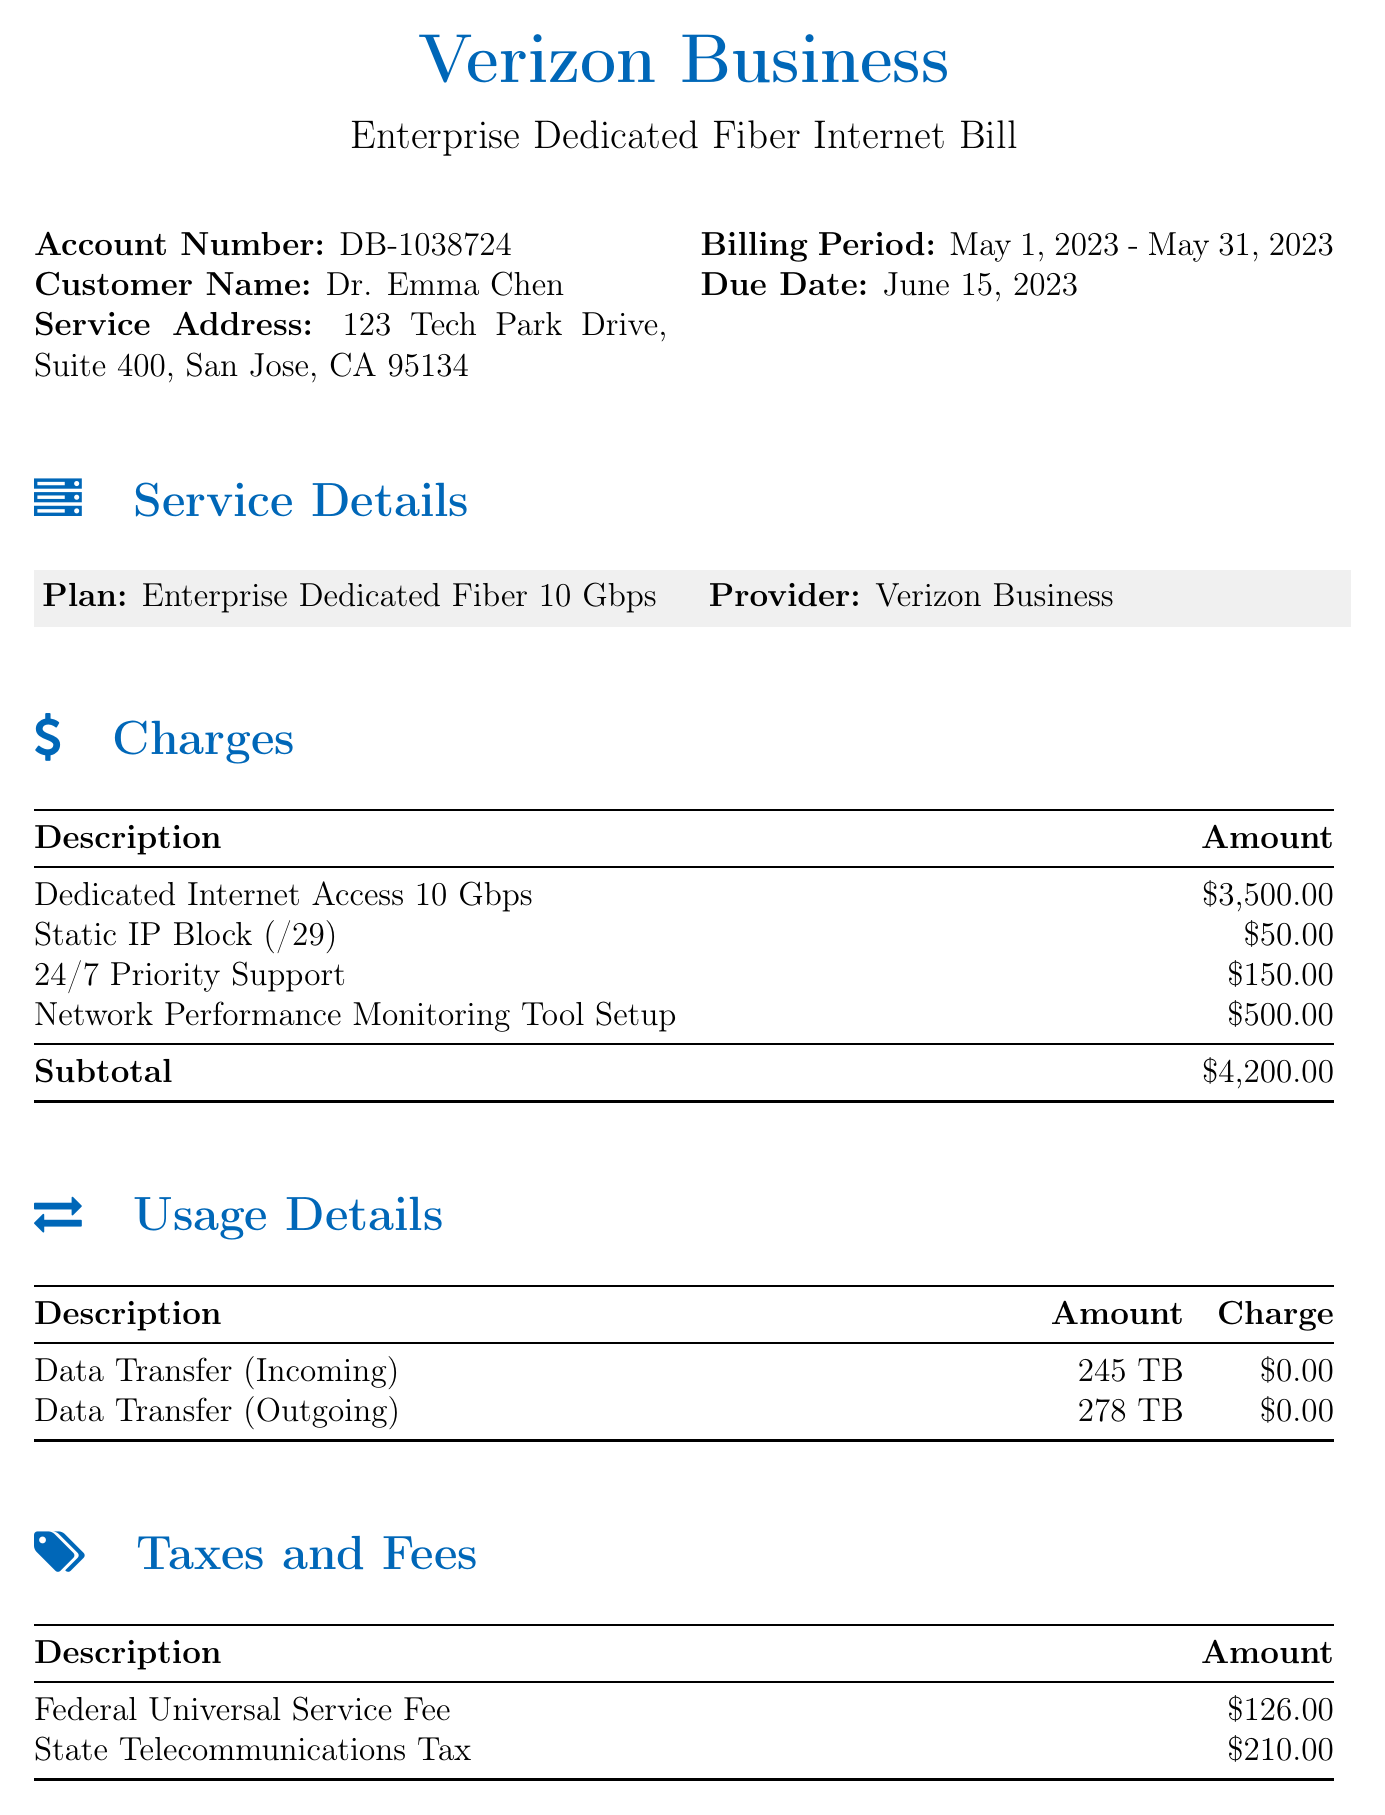What is the account number? The account number is listed in the document as part of the header information.
Answer: DB-1038724 What is the billing period? The billing period indicates the time frame for the services billed in this document.
Answer: May 1, 2023 - May 31, 2023 What is the total due amount? The total due is detailed at the bottom of the charges section as the final amount owed.
Answer: $4,536.00 How much is charged for Dedicated Internet Access? This charge is specified in the Charges section and stands as a primary service fee.
Answer: $3,500.00 What is the amount for the Static IP Block? This amount is also listed under the Charges section, outlining costs for additional features.
Answer: $50.00 What services are included in the usage details? The usage details show specific data transfer types that are not charged.
Answer: Data Transfer (Incoming) and Data Transfer (Outgoing) How many terabytes were transferred outgoing? This can be found in the usage details section, which lists outgoing data transfer volumes.
Answer: 278 TB What is the Federal Universal Service Fee? This fee is detailed under the Taxes and Fees section, contributing to the overall amount due.
Answer: $126.00 What is the provider of the internet service? The provider name is mentioned in the service details part of the document.
Answer: Verizon Business 